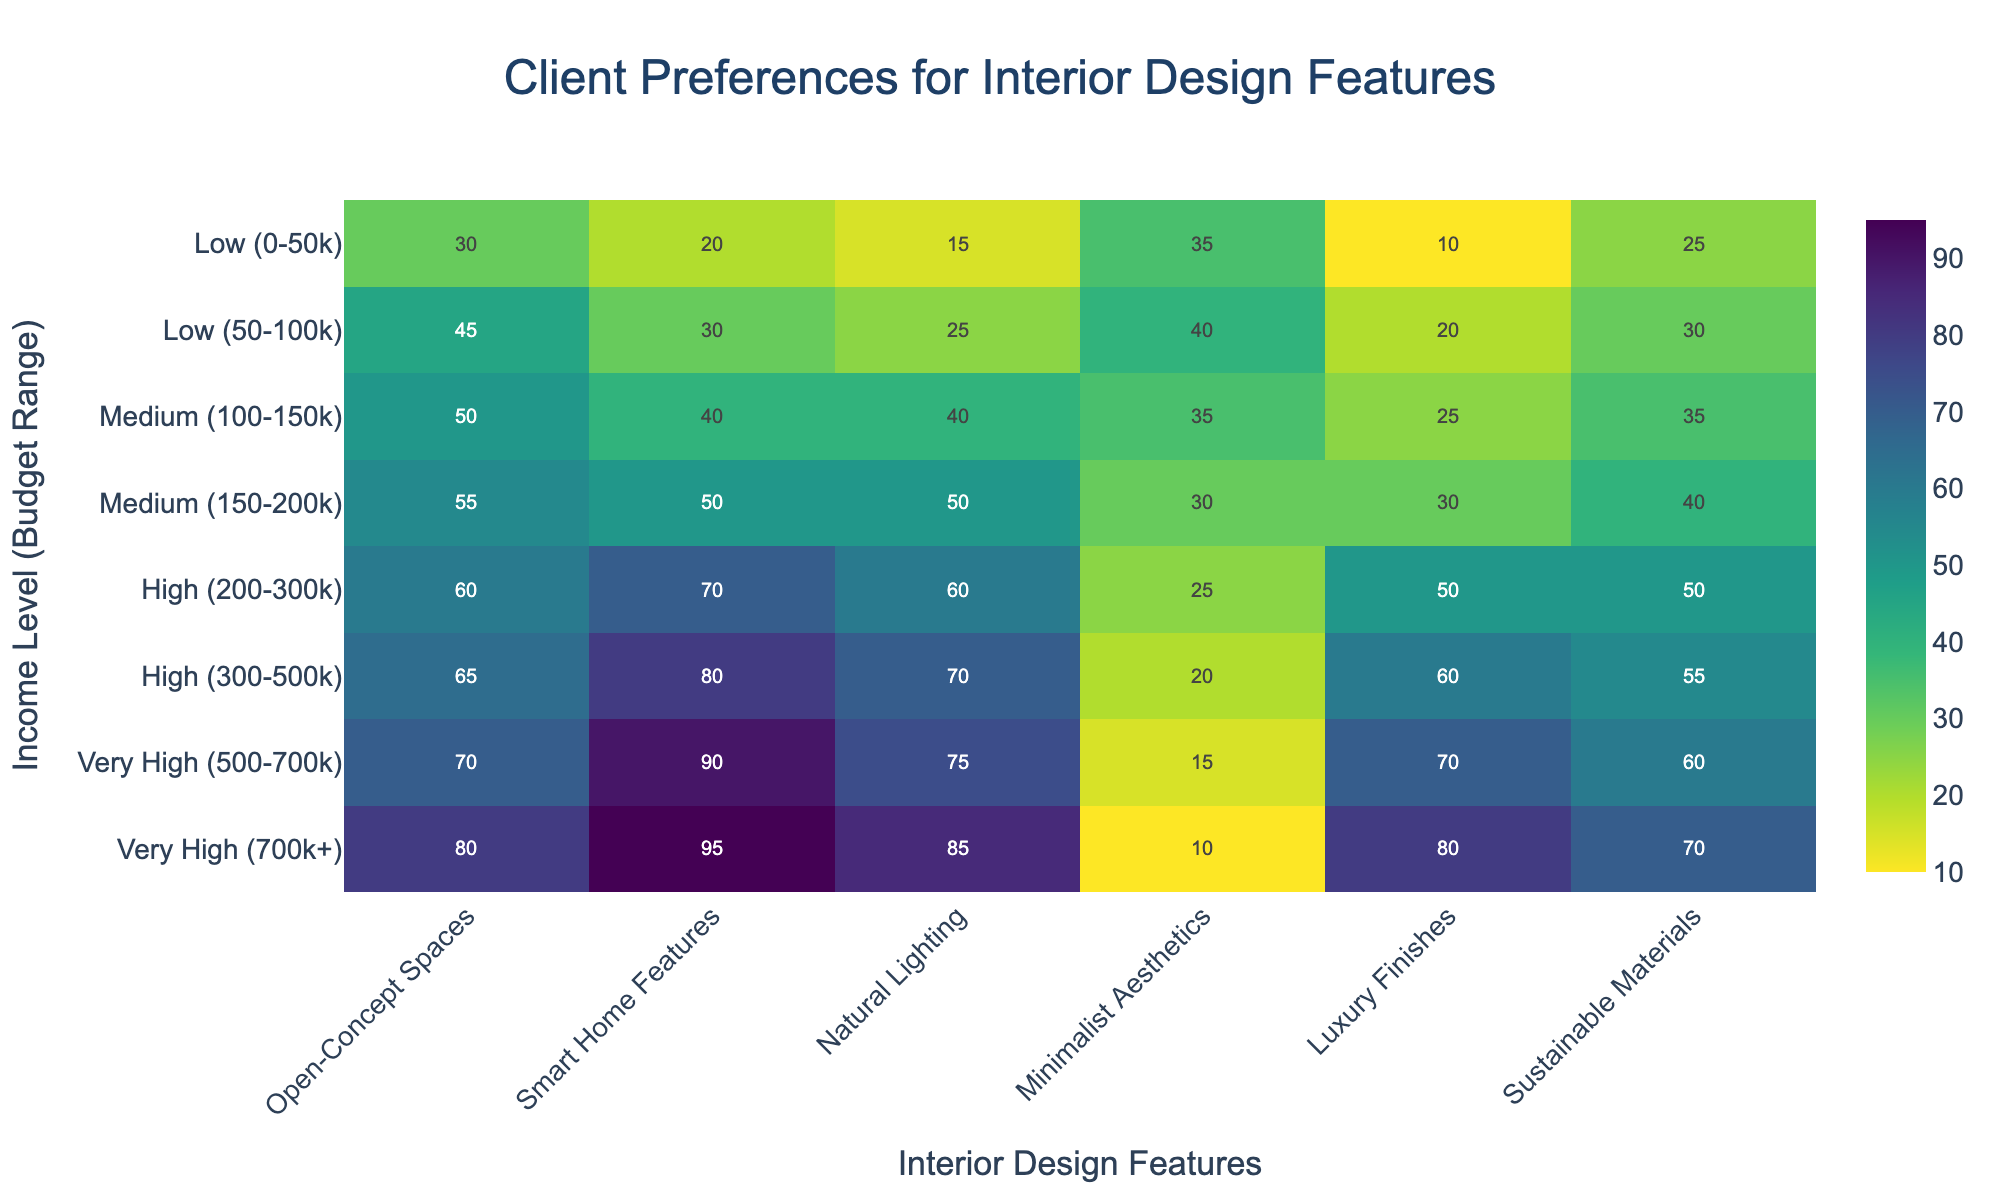what is the most preferred feature for clients with a very high income and the lowest budget range? To determine the most preferred feature in this category, look at the preferences for clients with a "Very High (500-700k)" budget. Compare the values for Open-Concept Spaces, Smart Home Features, Natural Lighting, Minimalist Aesthetics, Luxury Finishes, and Sustainable Materials. The highest value indicates the most preferred feature.
Answer: Smart Home Features which income level shows a preference of 45 for open-concept spaces? Find the cell under Open-Concept Spaces with a preference value of 45 by tracing it to its corresponding row. This row will indicate the income level and budget range associated with this preference.
Answer: Low (50-100k) how does the preference for minimalist aesthetics differ between high-income groups with different budget ranges? Compare the cells of Minimalist Aesthetics for High income levels with a budget of 200-300k and 300-500k. Note the difference in values between these two ranges.
Answer: Preference decreases from 25 to 20 what is the average preference for natural lighting across all income levels? Add up all the preference values for Natural Lighting across all Budget Ranges and income levels, then divide by the number of entries (8). This process involves simple arithmetic calculations. (15 + 25 + 40 + 50 + 60 + 70 + 75 + 85) / 8 = 52.5.
Answer: 52.5 is the preference for luxury finishes higher in medium or high-income categories? Compare the values for Luxury Finishes between Medium (both 100-150k and 150-200k) and High (both 200-300k and 300-500k) income levels. Note which category has higher values overall.
Answer: High income what trend in preferences do we observe for sustainable materials as the income level increases? Examine the heatmap values for Sustainable Materials across all income levels, noting how the values change from Low to Very High. Discuss any patterns, such as consistent increases, decreases, or fluctuations.
Answer: Preference increases as income level rises which feature has the most uniform preference across all income and budget levels? Identify the feature whose values show the least variability across all income and budget levels by visually assessing the consistency of color intensity in its column. This feature will have relatively similar values throughout.
Answer: Open-Concept Spaces how does the preference for smart home features change from low to very high-income levels? Look at the values under Smart Home Features across Low, Medium, High, and Very High income levels to identify the trend. Note whether the values increase, decrease, or stay constant as income levels rise.
Answer: Preference increases consistently what is the combined preference for natural lighting and luxury finishes for clients in the medium-income level with the highest budget range? Add the values of Natural Lighting and Luxury Finishes for the Medium (150-200k) category. This involves a straightforward addition of the two preference values (50 + 30).
Answer: 80 